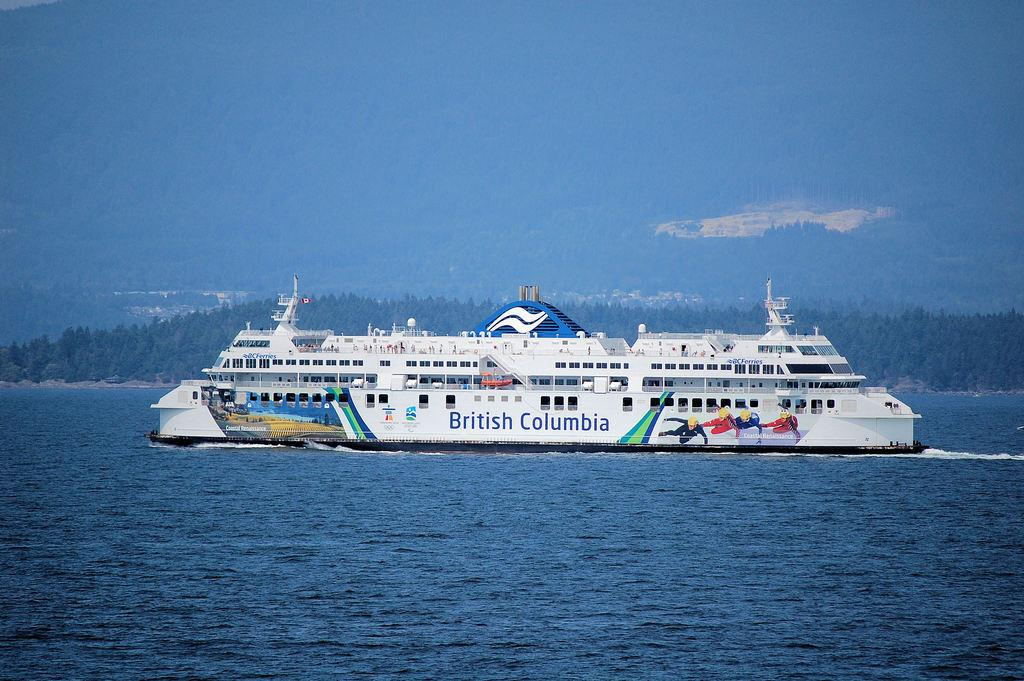<image>
Relay a brief, clear account of the picture shown. A British Columbia cruise ship sailing with mountains in the background. 